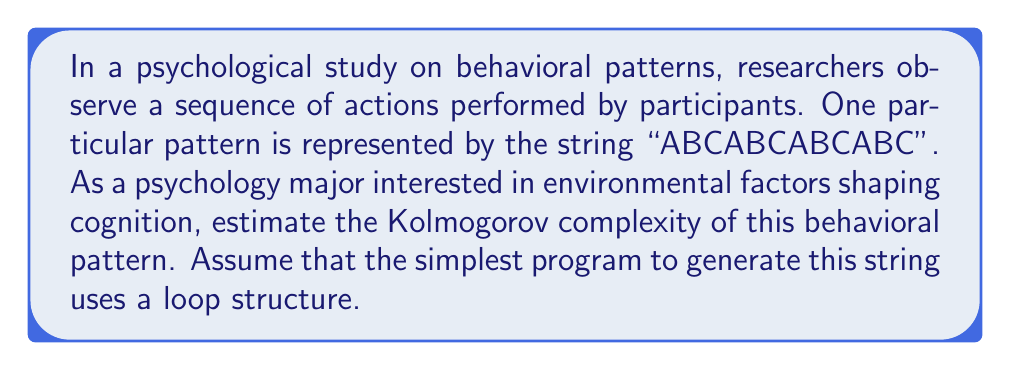What is the answer to this math problem? To estimate the Kolmogorov complexity of the given behavioral pattern, we need to consider the shortest possible program that could generate the string "ABCABCABCABC". This approach aligns with the concept of environmental factors shaping cognition, as we're looking at how the pattern can be most efficiently described or generated.

Let's break down the process:

1) Observe the pattern: The string "ABCABCABCABC" is a repetition of "ABC" four times.

2) Represent the pattern programmatically: We can use a loop to generate this pattern. In pseudocode, it might look like:

   ```
   repeat 4 times:
     print "ABC"
   ```

3) Estimate the complexity: To estimate the Kolmogorov complexity, we need to consider the information content of this program. We have:
   - A loop structure (approximately 10 bits)
   - The number 4 (approximately 3 bits)
   - The string "ABC" (3 characters, approximately 5 bits each = 15 bits)
   - A print command (approximately 10 bits)

4) Sum up the bits:
   $$ K(s) \approx 10 + 3 + 15 + 10 = 38 \text{ bits} $$

This estimation suggests that the Kolmogorov complexity of the given behavioral pattern is approximately 38 bits. This relatively low complexity indicates a highly structured and repetitive pattern, which could be interpreted in a psychological context as a learned or conditioned behavior shaped by environmental factors.
Answer: $$ K(s) \approx 38 \text{ bits} $$ 